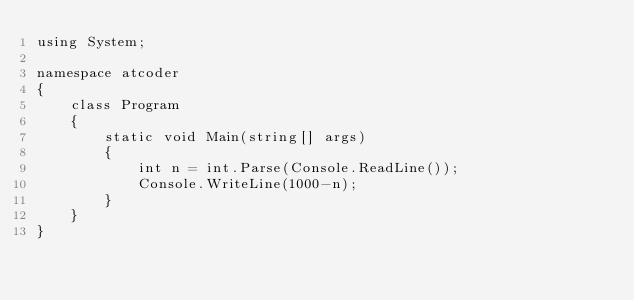<code> <loc_0><loc_0><loc_500><loc_500><_C#_>using System;

namespace atcoder
{
    class Program
    {
        static void Main(string[] args)
        {
            int n = int.Parse(Console.ReadLine());
            Console.WriteLine(1000-n);
        }
    }
}
</code> 